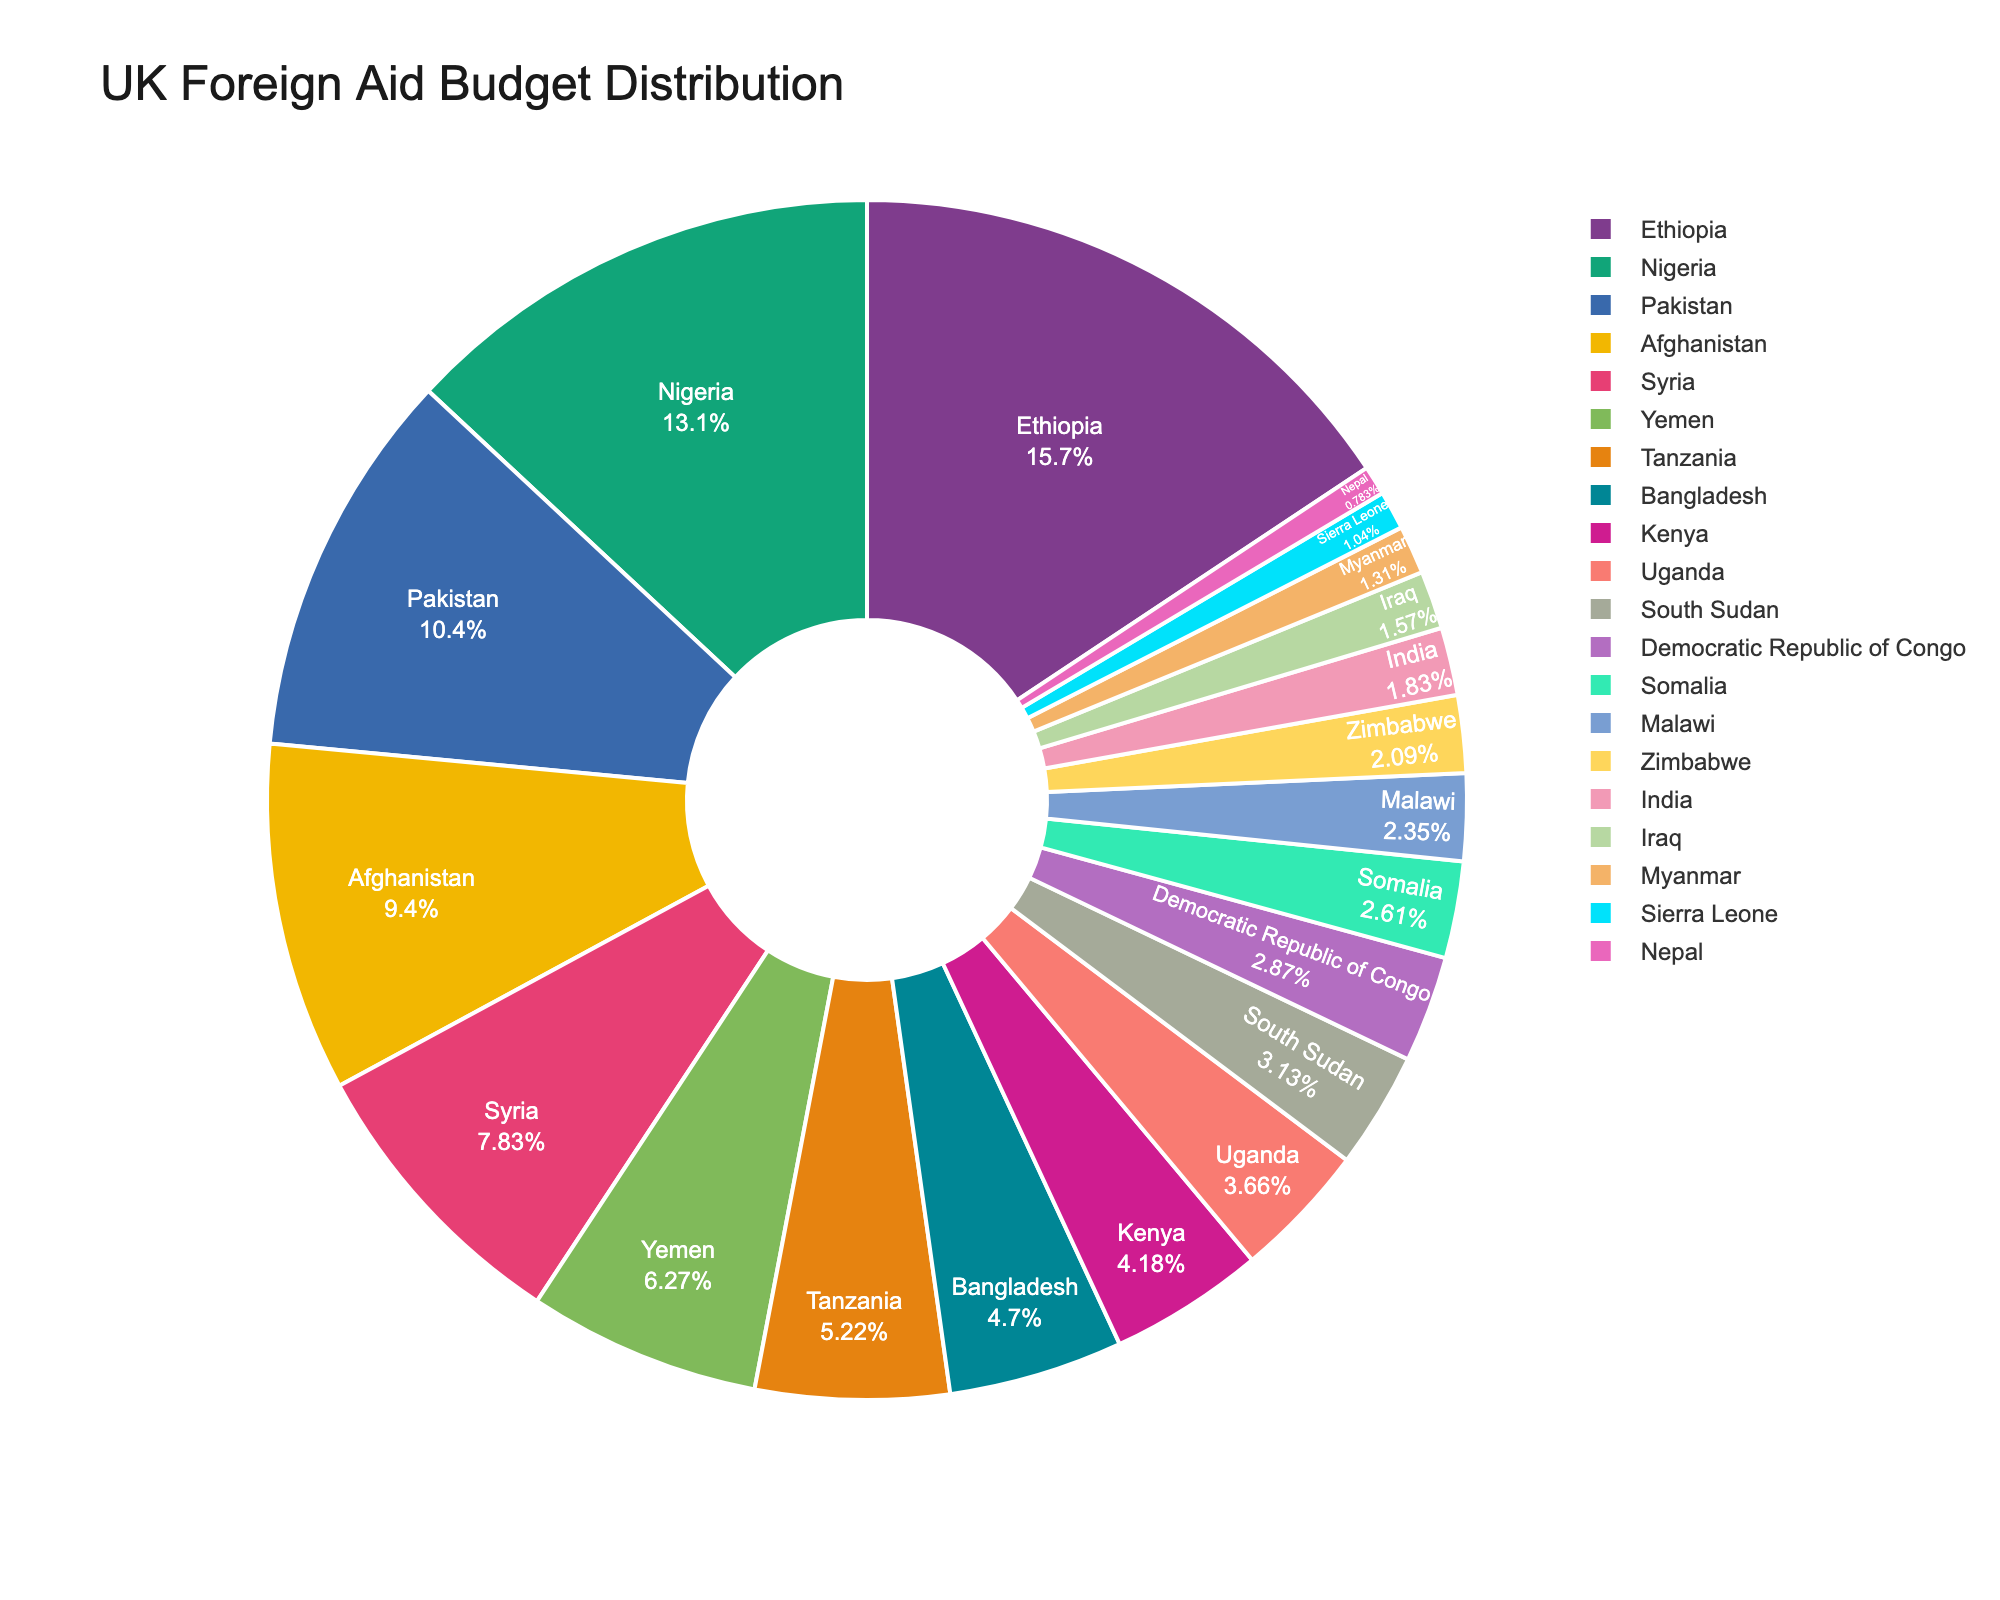what percentage of the UK's foreign aid budget goes to Ethiopia? Ethiopia is a segment in the pie chart. To find the percentage, look at the label or tooltip for Ethiopia. It shows the portion assigned to Ethiopia relative to the total budget.
Answer: 14.63% Which country receives more aid: Afghanistan or Syria? Afghanistan and Syria are both segments in the pie chart. Compare the sizes of the two segments visually or refer to the labels to see which has a larger share.
Answer: Afghanistan How much more aid does Nigeria receive compared to Bangladesh? Locate Nigeria and Bangladesh on the pie chart. Nigeria receives £250 million, and Bangladesh receives £90 million. Subtract the aid for Bangladesh from the aid for Nigeria to find the difference: 250 - 90.
Answer: £160 million Which country has the smallest share of the UK's foreign aid budget? Identify the smallest segment in the pie chart, which corresponds to the smallest aid allocation. The label or tooltip will specify the country with the smallest share.
Answer: Nepal What is the total aid budget for the top 3 recipient countries? Locate the top 3 recipient countries in the pie chart: Ethiopia (£300 million), Nigeria (£250 million), and Pakistan (£200 million). Add their budgets together: 300 + 250 + 200.
Answer: £750 million What is the average aid budget for countries receiving between £50 million and £100 million? Identify the countries within the £50-£100 million range from the pie chart: Tanzania (£100 million), Bangladesh (£90 million), Kenya (£80 million), Uganda (£70 million), South Sudan (£60 million), Democratic Republic of Congo (£55 million), Somalia (£50 million). Sum their budgets: 100 + 90 + 80 + 70 + 60 + 55 + 50 = 505. Divide by the number of countries, 7: 505 / 7.
Answer: £72.14 million Which recipients have an aid budget closest to £100 million? Locate the segments near the £100 million mark in the pie chart. Tanzania receives exactly £100 million.
Answer: Tanzania How much larger is the budget for Yemen compared to India? Locate Yemen and India in the pie chart. Yemen receives £120 million, and India receives £35 million. Subtract India's budget from Yemen's budget: 120 - 35.
Answer: £85 million Which color represents Ethiopia in the pie chart? Identify the segment for Ethiopia in the pie chart and note its color visually. The color assigned by the plotly color sequence for Ethiopia will be visible in the legend.
Answer: [Color according to visual inspection] 